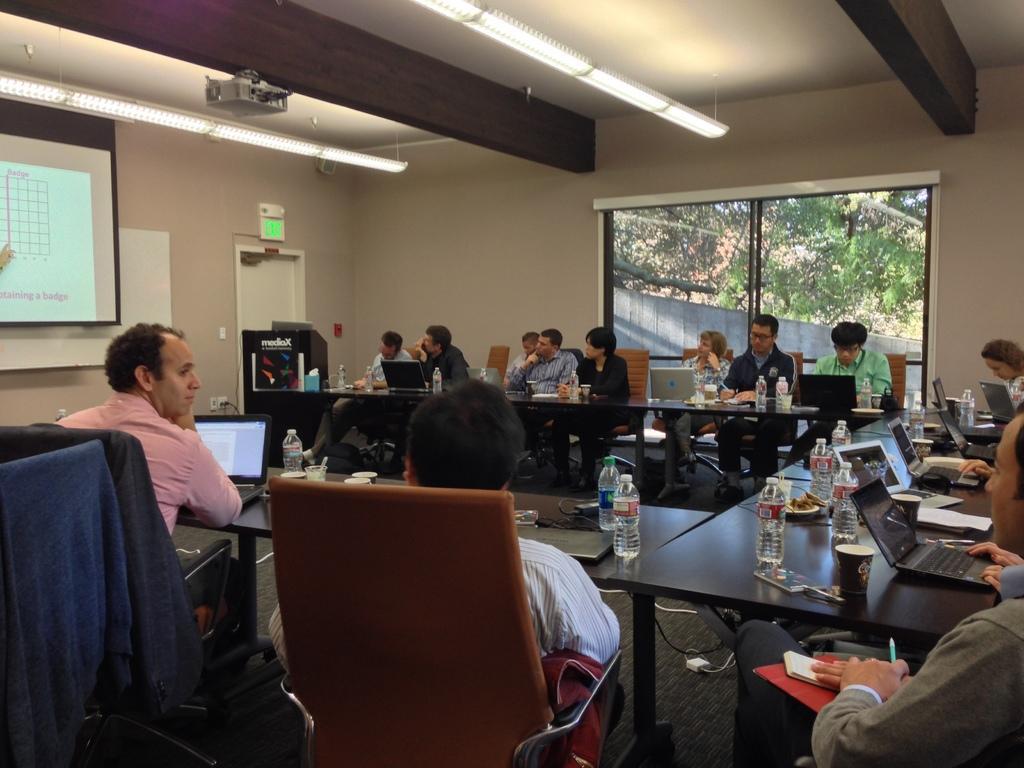In one or two sentences, can you explain what this image depicts? In this image I can see number of people are sitting on chairs. On these tables I can see of laptops, bottles and few cups. Here I can see a projector's screen. 